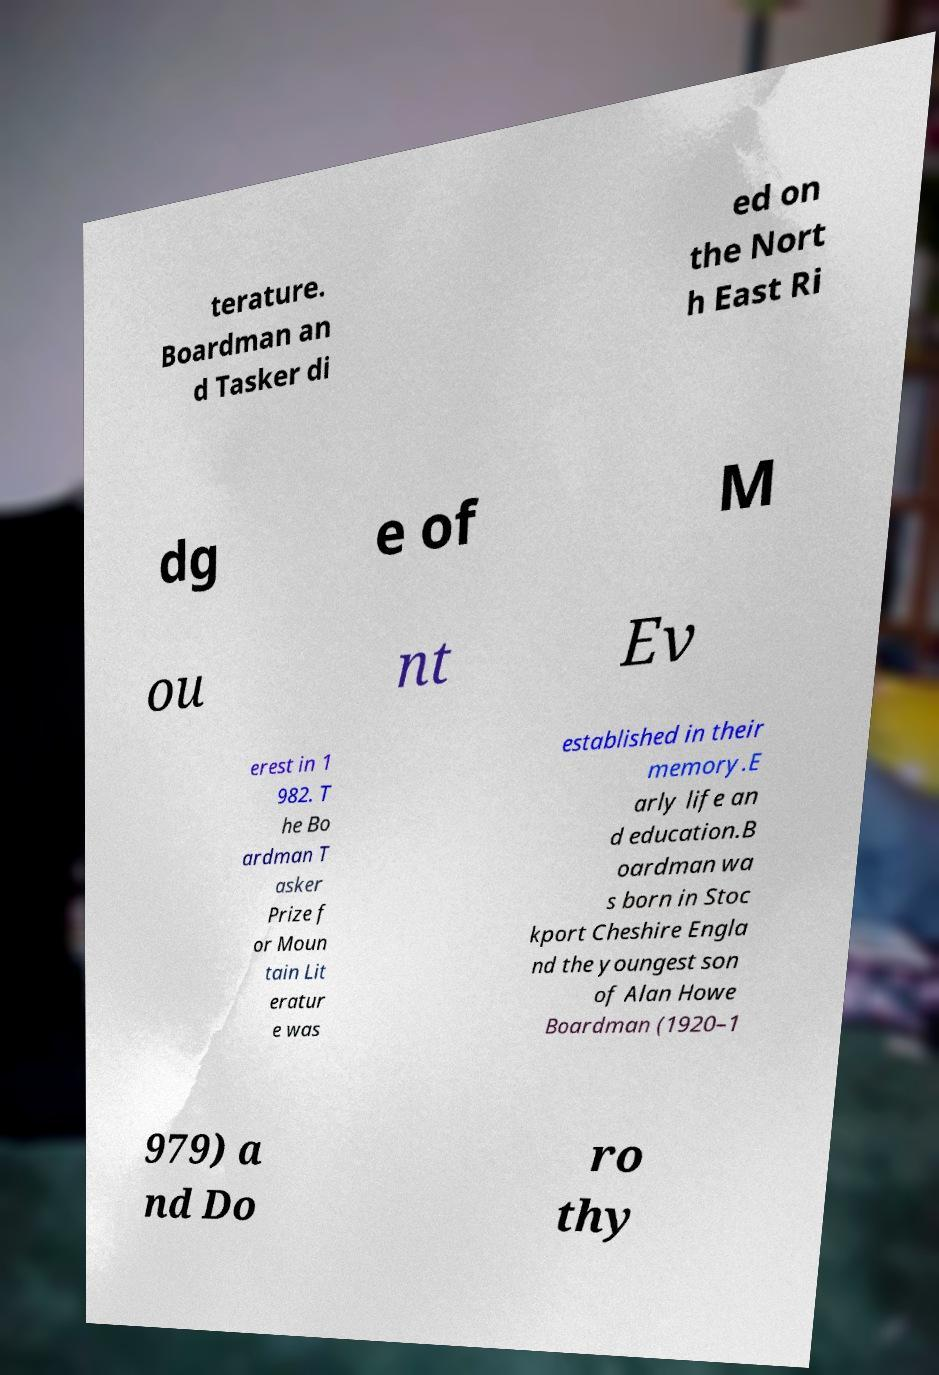What messages or text are displayed in this image? I need them in a readable, typed format. terature. Boardman an d Tasker di ed on the Nort h East Ri dg e of M ou nt Ev erest in 1 982. T he Bo ardman T asker Prize f or Moun tain Lit eratur e was established in their memory.E arly life an d education.B oardman wa s born in Stoc kport Cheshire Engla nd the youngest son of Alan Howe Boardman (1920–1 979) a nd Do ro thy 